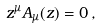Convert formula to latex. <formula><loc_0><loc_0><loc_500><loc_500>z ^ { \mu } A _ { \mu } ( z ) = 0 \, ,</formula> 